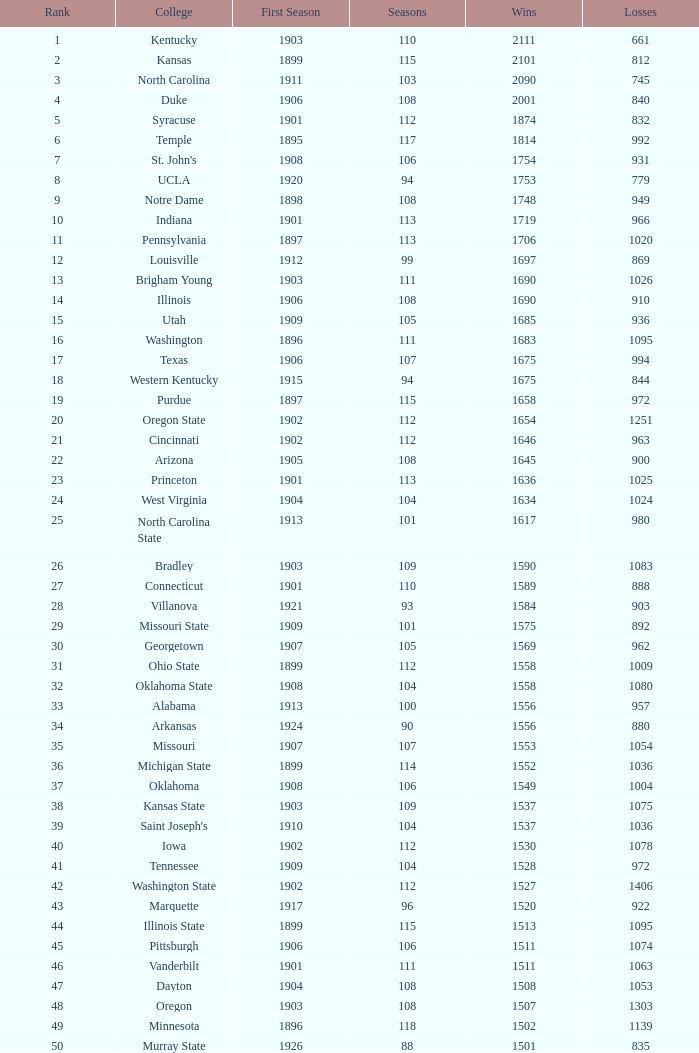What is the total number of rank with losses less than 992, North Carolina State College and a season greater than 101? 0.0. Could you help me parse every detail presented in this table? {'header': ['Rank', 'College', 'First Season', 'Seasons', 'Wins', 'Losses'], 'rows': [['1', 'Kentucky', '1903', '110', '2111', '661'], ['2', 'Kansas', '1899', '115', '2101', '812'], ['3', 'North Carolina', '1911', '103', '2090', '745'], ['4', 'Duke', '1906', '108', '2001', '840'], ['5', 'Syracuse', '1901', '112', '1874', '832'], ['6', 'Temple', '1895', '117', '1814', '992'], ['7', "St. John's", '1908', '106', '1754', '931'], ['8', 'UCLA', '1920', '94', '1753', '779'], ['9', 'Notre Dame', '1898', '108', '1748', '949'], ['10', 'Indiana', '1901', '113', '1719', '966'], ['11', 'Pennsylvania', '1897', '113', '1706', '1020'], ['12', 'Louisville', '1912', '99', '1697', '869'], ['13', 'Brigham Young', '1903', '111', '1690', '1026'], ['14', 'Illinois', '1906', '108', '1690', '910'], ['15', 'Utah', '1909', '105', '1685', '936'], ['16', 'Washington', '1896', '111', '1683', '1095'], ['17', 'Texas', '1906', '107', '1675', '994'], ['18', 'Western Kentucky', '1915', '94', '1675', '844'], ['19', 'Purdue', '1897', '115', '1658', '972'], ['20', 'Oregon State', '1902', '112', '1654', '1251'], ['21', 'Cincinnati', '1902', '112', '1646', '963'], ['22', 'Arizona', '1905', '108', '1645', '900'], ['23', 'Princeton', '1901', '113', '1636', '1025'], ['24', 'West Virginia', '1904', '104', '1634', '1024'], ['25', 'North Carolina State', '1913', '101', '1617', '980'], ['26', 'Bradley', '1903', '109', '1590', '1083'], ['27', 'Connecticut', '1901', '110', '1589', '888'], ['28', 'Villanova', '1921', '93', '1584', '903'], ['29', 'Missouri State', '1909', '101', '1575', '892'], ['30', 'Georgetown', '1907', '105', '1569', '962'], ['31', 'Ohio State', '1899', '112', '1558', '1009'], ['32', 'Oklahoma State', '1908', '104', '1558', '1080'], ['33', 'Alabama', '1913', '100', '1556', '957'], ['34', 'Arkansas', '1924', '90', '1556', '880'], ['35', 'Missouri', '1907', '107', '1553', '1054'], ['36', 'Michigan State', '1899', '114', '1552', '1036'], ['37', 'Oklahoma', '1908', '106', '1549', '1004'], ['38', 'Kansas State', '1903', '109', '1537', '1075'], ['39', "Saint Joseph's", '1910', '104', '1537', '1036'], ['40', 'Iowa', '1902', '112', '1530', '1078'], ['41', 'Tennessee', '1909', '104', '1528', '972'], ['42', 'Washington State', '1902', '112', '1527', '1406'], ['43', 'Marquette', '1917', '96', '1520', '922'], ['44', 'Illinois State', '1899', '115', '1513', '1095'], ['45', 'Pittsburgh', '1906', '106', '1511', '1074'], ['46', 'Vanderbilt', '1901', '111', '1511', '1063'], ['47', 'Dayton', '1904', '108', '1508', '1053'], ['48', 'Oregon', '1903', '108', '1507', '1303'], ['49', 'Minnesota', '1896', '118', '1502', '1139'], ['50', 'Murray State', '1926', '88', '1501', '835']]} 